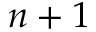<formula> <loc_0><loc_0><loc_500><loc_500>n + 1</formula> 